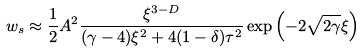<formula> <loc_0><loc_0><loc_500><loc_500>w _ { s } \approx \frac { 1 } { 2 } A ^ { 2 } \frac { \xi ^ { 3 - D } } { ( \gamma - 4 ) \xi ^ { 2 } + 4 ( 1 - \delta ) \tau ^ { 2 } } \exp \left ( - 2 \sqrt { 2 \gamma } \xi \right )</formula> 